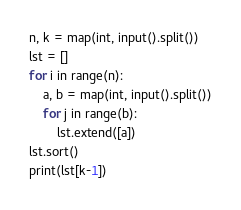<code> <loc_0><loc_0><loc_500><loc_500><_Python_>n, k = map(int, input().split())
lst = []
for i in range(n):
    a, b = map(int, input().split())
    for j in range(b):
        lst.extend([a])
lst.sort()
print(lst[k-1])</code> 